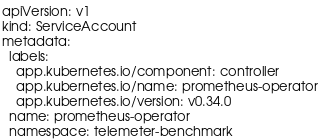<code> <loc_0><loc_0><loc_500><loc_500><_YAML_>apiVersion: v1
kind: ServiceAccount
metadata:
  labels:
    app.kubernetes.io/component: controller
    app.kubernetes.io/name: prometheus-operator
    app.kubernetes.io/version: v0.34.0
  name: prometheus-operator
  namespace: telemeter-benchmark
</code> 